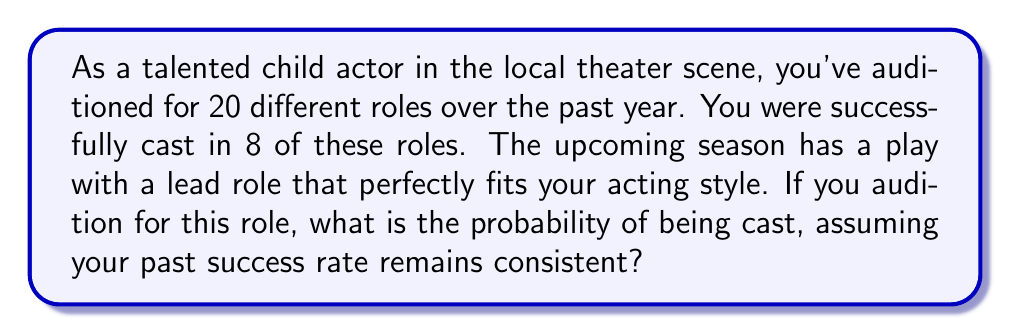What is the answer to this math problem? To solve this problem, we need to use the concept of probability based on past events. Here's a step-by-step explanation:

1. Calculate the success rate from past auditions:
   - Total auditions: 20
   - Successful castings: 8
   
   Success rate = $\frac{\text{Successful castings}}{\text{Total auditions}}$
   
   $$\text{Success rate} = \frac{8}{20} = 0.4 = 40\%$$

2. Assuming this success rate remains consistent for future auditions, we can use it as the probability of being cast for the upcoming role.

3. The probability of being cast in the specific role is equal to the calculated success rate:

   $$P(\text{being cast}) = 0.4 = 40\%$$

This means that based on your past performance, you have a 40% chance of being cast in this new role.
Answer: The probability of being cast in the specific role is 0.4 or 40%. 